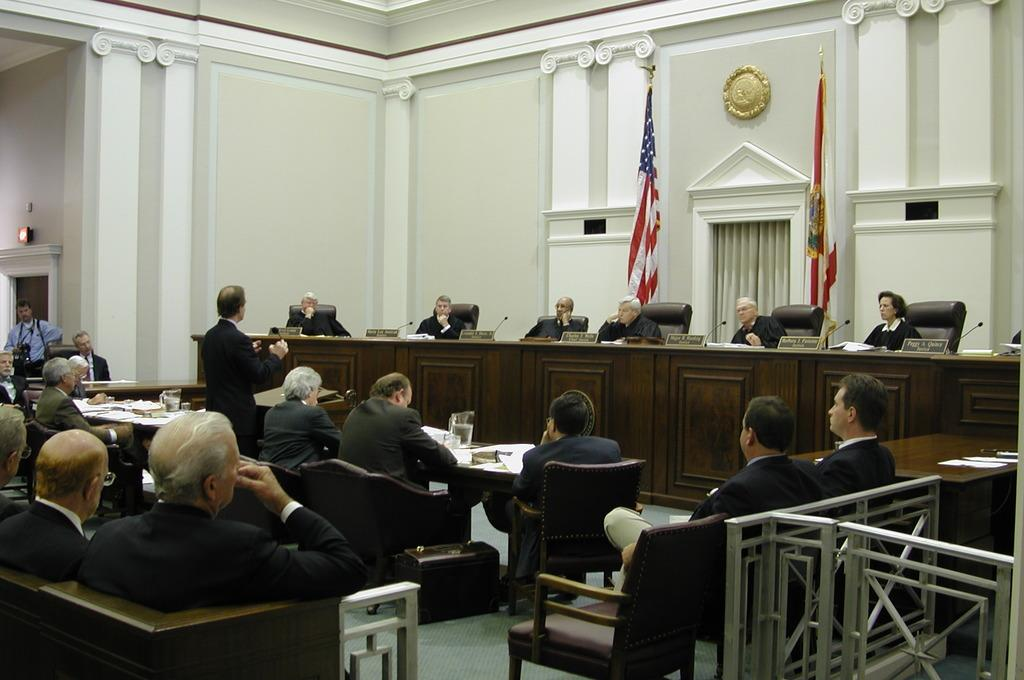What are the people in the image doing? There are people sitting on chairs and standing in the image. What can be seen in the background or alongside the people? There are two flags in the image. What type of rhythm can be heard coming from the moon in the image? There is no moon present in the image, and therefore no rhythm can be heard from it. 